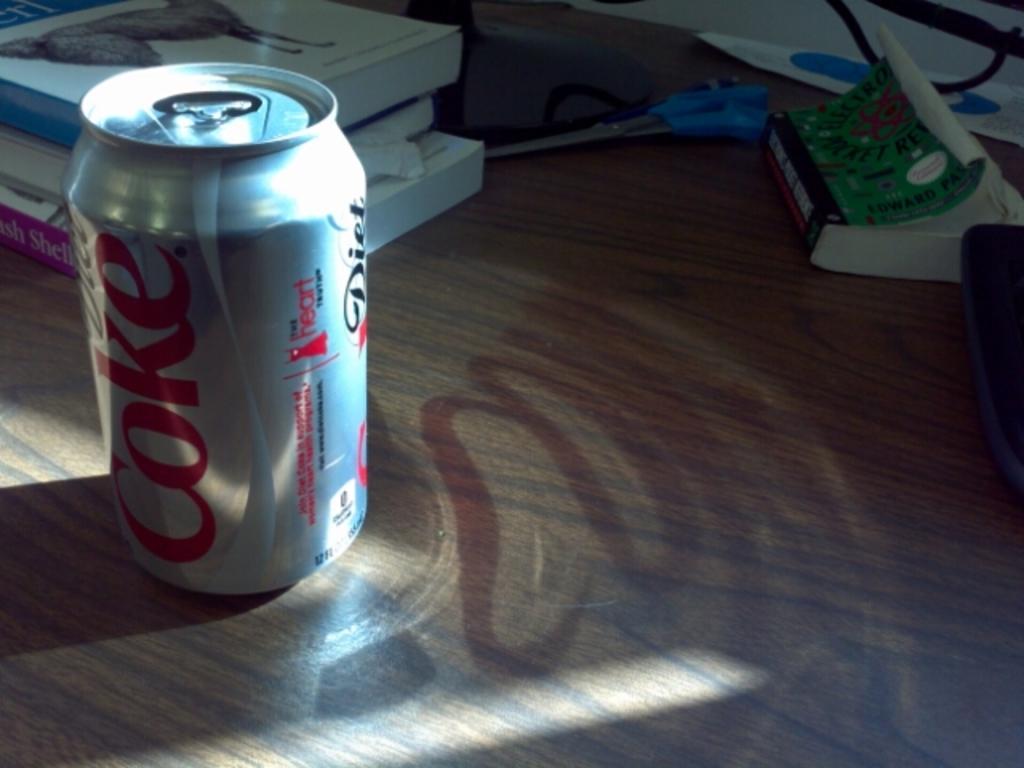Is the shadow of the coke caused by the can of coke?
Provide a succinct answer. Yes. What brand of soda is in the can?
Give a very brief answer. Diet coke. 